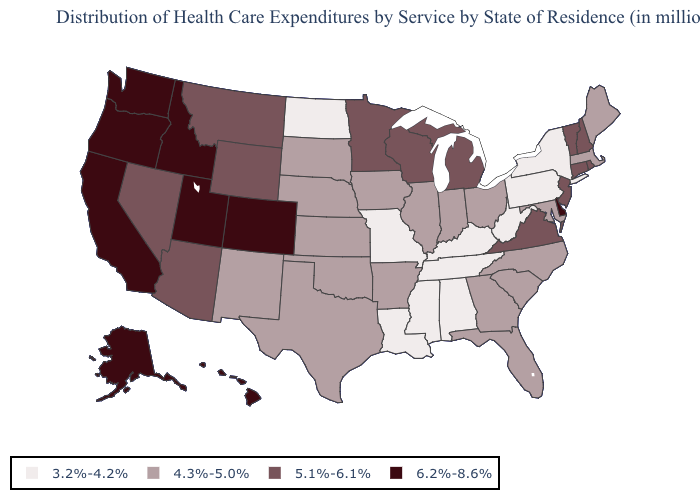Name the states that have a value in the range 6.2%-8.6%?
Short answer required. Alaska, California, Colorado, Delaware, Hawaii, Idaho, Oregon, Utah, Washington. Name the states that have a value in the range 3.2%-4.2%?
Quick response, please. Alabama, Kentucky, Louisiana, Mississippi, Missouri, New York, North Dakota, Pennsylvania, Tennessee, West Virginia. What is the value of Florida?
Keep it brief. 4.3%-5.0%. Which states have the highest value in the USA?
Give a very brief answer. Alaska, California, Colorado, Delaware, Hawaii, Idaho, Oregon, Utah, Washington. Name the states that have a value in the range 4.3%-5.0%?
Be succinct. Arkansas, Florida, Georgia, Illinois, Indiana, Iowa, Kansas, Maine, Maryland, Massachusetts, Nebraska, New Mexico, North Carolina, Ohio, Oklahoma, South Carolina, South Dakota, Texas. Which states have the lowest value in the South?
Give a very brief answer. Alabama, Kentucky, Louisiana, Mississippi, Tennessee, West Virginia. How many symbols are there in the legend?
Concise answer only. 4. What is the lowest value in the USA?
Keep it brief. 3.2%-4.2%. Name the states that have a value in the range 4.3%-5.0%?
Answer briefly. Arkansas, Florida, Georgia, Illinois, Indiana, Iowa, Kansas, Maine, Maryland, Massachusetts, Nebraska, New Mexico, North Carolina, Ohio, Oklahoma, South Carolina, South Dakota, Texas. Name the states that have a value in the range 5.1%-6.1%?
Write a very short answer. Arizona, Connecticut, Michigan, Minnesota, Montana, Nevada, New Hampshire, New Jersey, Rhode Island, Vermont, Virginia, Wisconsin, Wyoming. Name the states that have a value in the range 6.2%-8.6%?
Concise answer only. Alaska, California, Colorado, Delaware, Hawaii, Idaho, Oregon, Utah, Washington. Is the legend a continuous bar?
Keep it brief. No. What is the value of Washington?
Be succinct. 6.2%-8.6%. Name the states that have a value in the range 5.1%-6.1%?
Short answer required. Arizona, Connecticut, Michigan, Minnesota, Montana, Nevada, New Hampshire, New Jersey, Rhode Island, Vermont, Virginia, Wisconsin, Wyoming. What is the highest value in states that border Rhode Island?
Keep it brief. 5.1%-6.1%. 